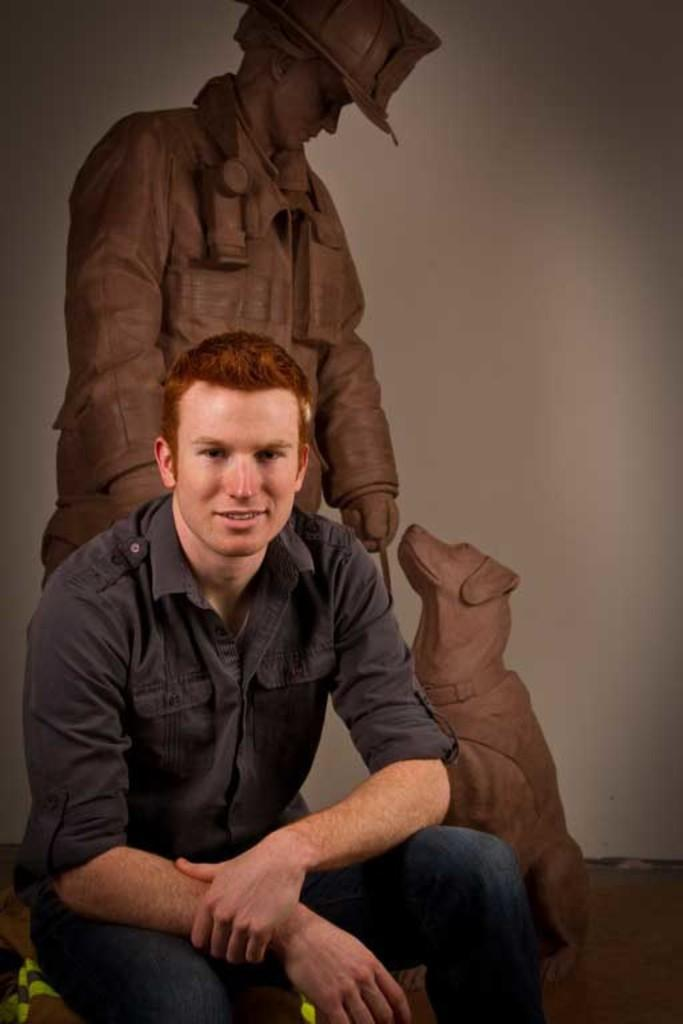Who or what can be seen in the image? There is a person in the image. What is the person wearing? The person is wearing a black color shirt. What is the person doing in the image? The person is sitting. What can be seen in the background of the image? There is a statue in the background of the image. What does the statue depict? The statue depicts a person and a dog. What type of expansion is taking place in the image? There is no expansion taking place in the image. What kind of structure can be seen in the field in the image? There is no field present in the image, and therefore no structure can be seen in a field. 